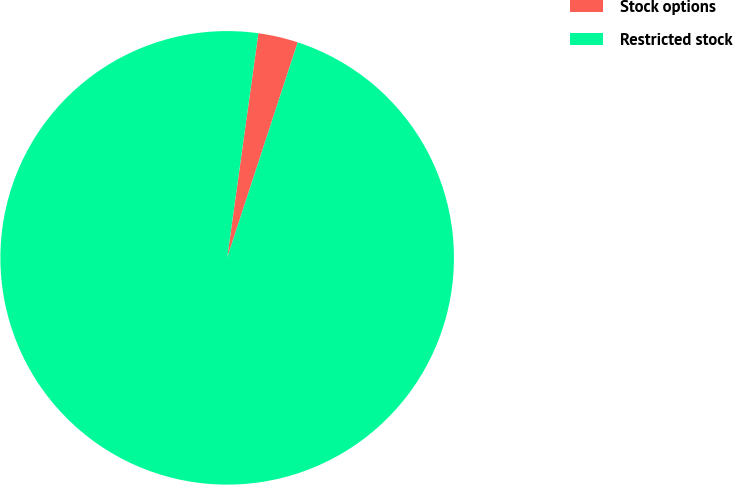<chart> <loc_0><loc_0><loc_500><loc_500><pie_chart><fcel>Stock options<fcel>Restricted stock<nl><fcel>2.84%<fcel>97.16%<nl></chart> 